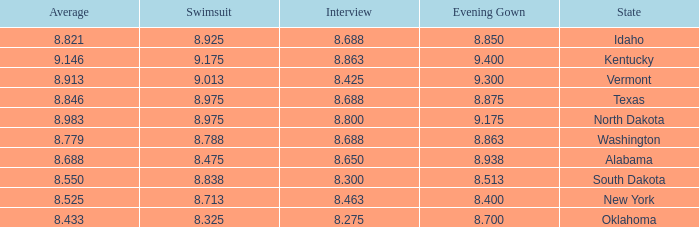What is the lowest evening score of the contestant with an evening gown less than 8.938, from Texas, and with an average less than 8.846 has? None. 